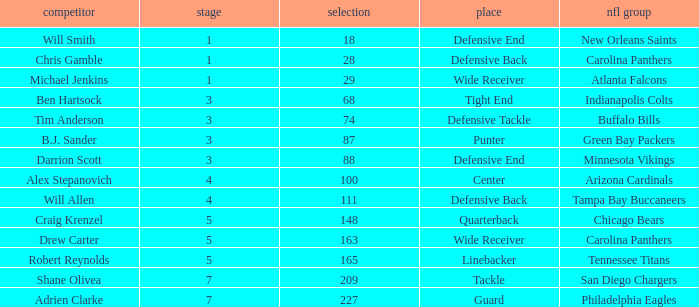What is the average Round number of Player Adrien Clarke? 7.0. 